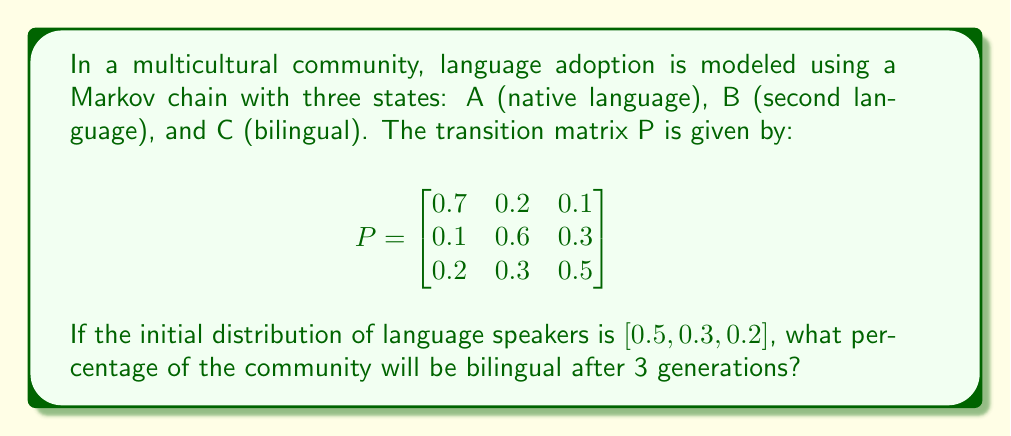Provide a solution to this math problem. To solve this problem, we need to follow these steps:

1. Identify the initial state vector and transition matrix:
   Initial state vector: $\pi_0 = [0.5, 0.3, 0.2]$
   Transition matrix: $P$ (given in the question)

2. Calculate the state vector after 3 generations:
   $\pi_3 = \pi_0 \cdot P^3$

3. To find $P^3$, we need to multiply P by itself three times:
   $P^2 = P \cdot P$
   $P^3 = P^2 \cdot P$

4. Using matrix multiplication (which can be done using a calculator or computer):
   
   $$P^2 = \begin{bmatrix}
   0.52 & 0.27 & 0.21 \\
   0.22 & 0.45 & 0.33 \\
   0.31 & 0.36 & 0.33
   \end{bmatrix}$$

   $$P^3 = \begin{bmatrix}
   0.443 & 0.312 & 0.245 \\
   0.289 & 0.387 & 0.324 \\
   0.352 & 0.360 & 0.288
   \end{bmatrix}$$

5. Now, multiply the initial state vector by $P^3$:
   $\pi_3 = [0.5, 0.3, 0.2] \cdot \begin{bmatrix}
   0.443 & 0.312 & 0.245 \\
   0.289 & 0.387 & 0.324 \\
   0.352 & 0.360 & 0.288
   \end{bmatrix}$

6. Performing the matrix multiplication:
   $\pi_3 = [0.3815, 0.3378, 0.2807]$

7. The percentage of bilingual speakers after 3 generations is the third component of $\pi_3$, which represents state C (bilingual).

8. Convert to percentage: $0.2807 \times 100\% = 28.07\%$
Answer: 28.07% 